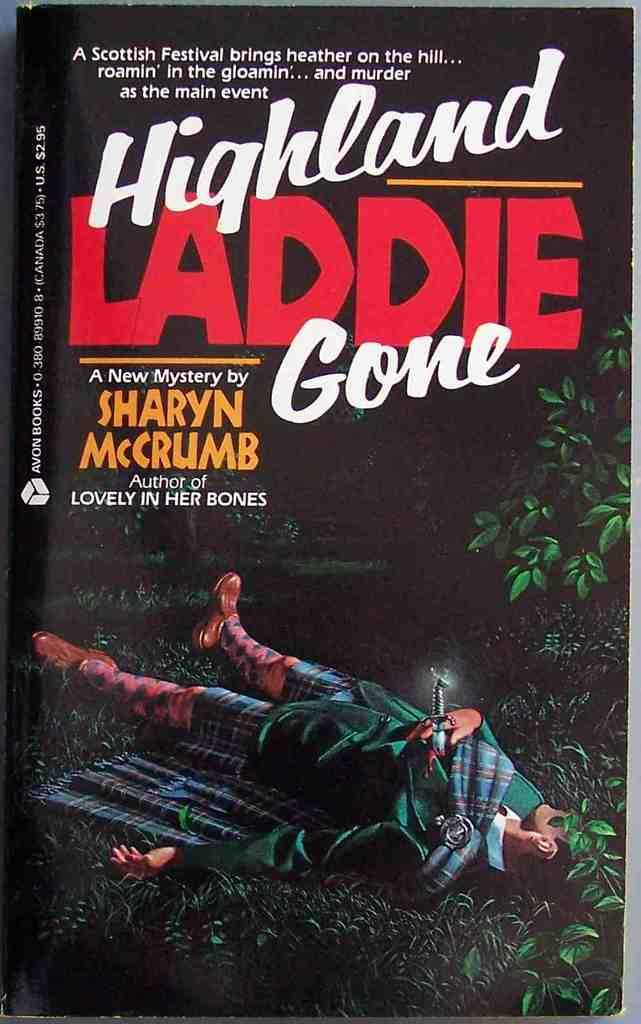<image>
Give a short and clear explanation of the subsequent image. Book cover showing a man in grass written by Sharyn Mccrumb. 